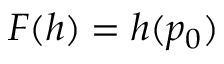Convert formula to latex. <formula><loc_0><loc_0><loc_500><loc_500>F ( h ) = h ( p _ { 0 } )</formula> 